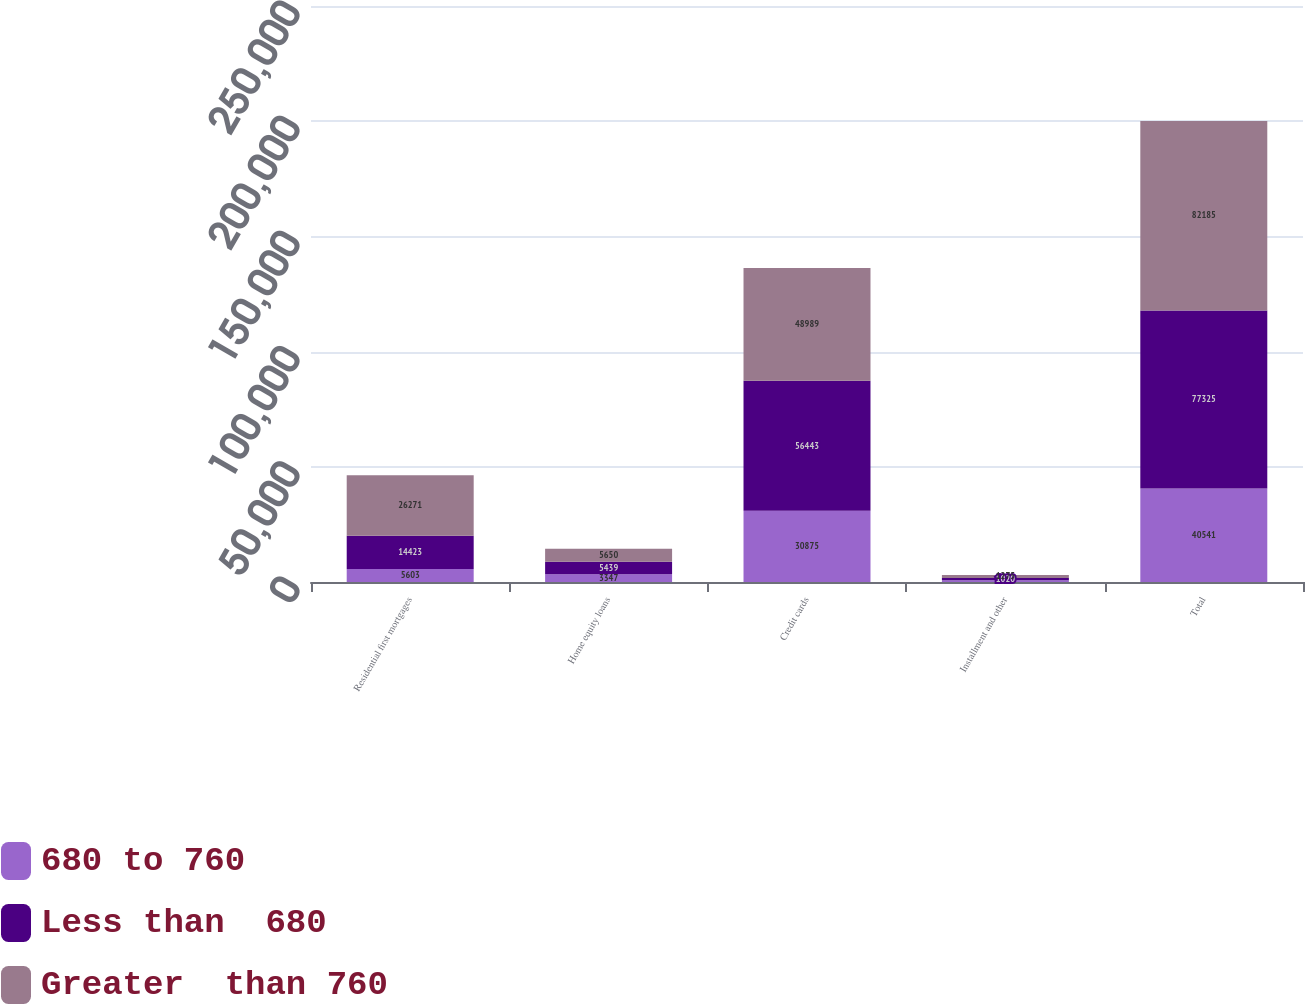Convert chart to OTSL. <chart><loc_0><loc_0><loc_500><loc_500><stacked_bar_chart><ecel><fcel>Residential first mortgages<fcel>Home equity loans<fcel>Credit cards<fcel>Installment and other<fcel>Total<nl><fcel>680 to 760<fcel>5603<fcel>3347<fcel>30875<fcel>716<fcel>40541<nl><fcel>Less than  680<fcel>14423<fcel>5439<fcel>56443<fcel>1020<fcel>77325<nl><fcel>Greater  than 760<fcel>26271<fcel>5650<fcel>48989<fcel>1275<fcel>82185<nl></chart> 